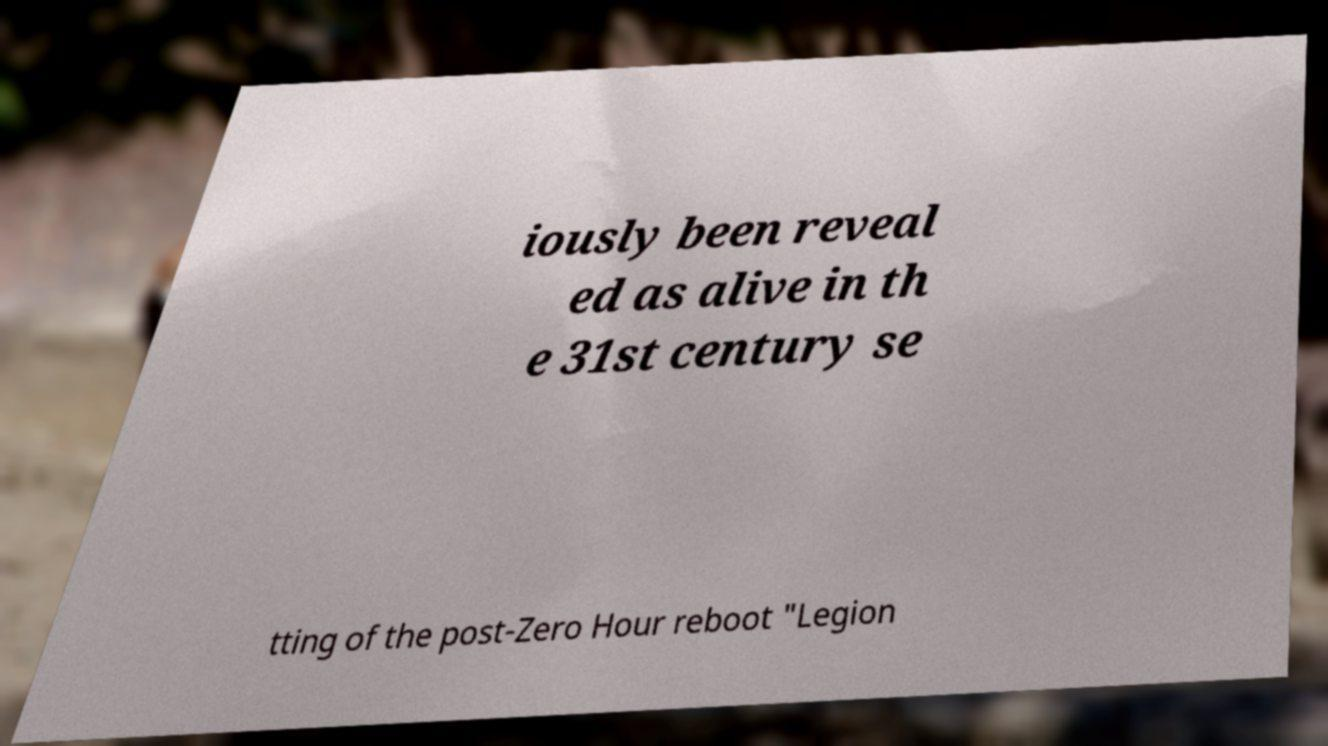There's text embedded in this image that I need extracted. Can you transcribe it verbatim? iously been reveal ed as alive in th e 31st century se tting of the post-Zero Hour reboot "Legion 